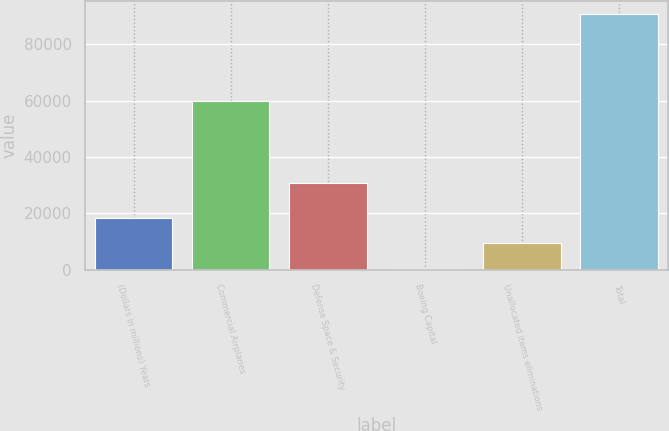<chart> <loc_0><loc_0><loc_500><loc_500><bar_chart><fcel>(Dollars in millions) Years<fcel>Commercial Airplanes<fcel>Defense Space & Security<fcel>Boeing Capital<fcel>Unallocated items eliminations<fcel>Total<nl><fcel>18485.2<fcel>59990<fcel>30881<fcel>416<fcel>9450.6<fcel>90762<nl></chart> 